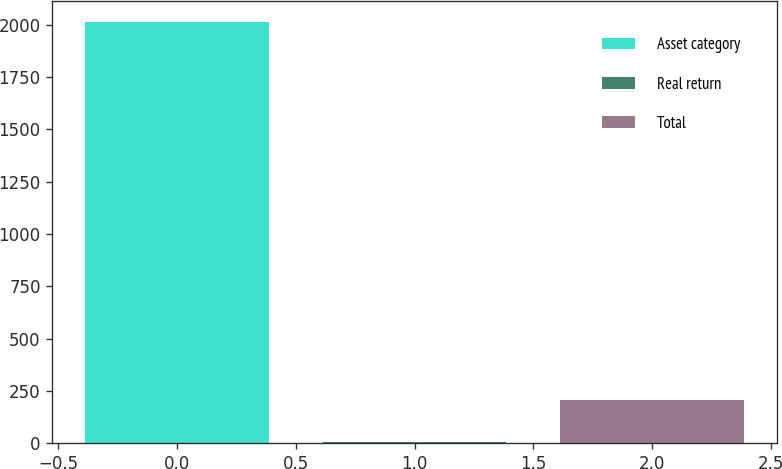<chart> <loc_0><loc_0><loc_500><loc_500><bar_chart><fcel>Asset category<fcel>Real return<fcel>Total<nl><fcel>2015<fcel>4.01<fcel>205.11<nl></chart> 